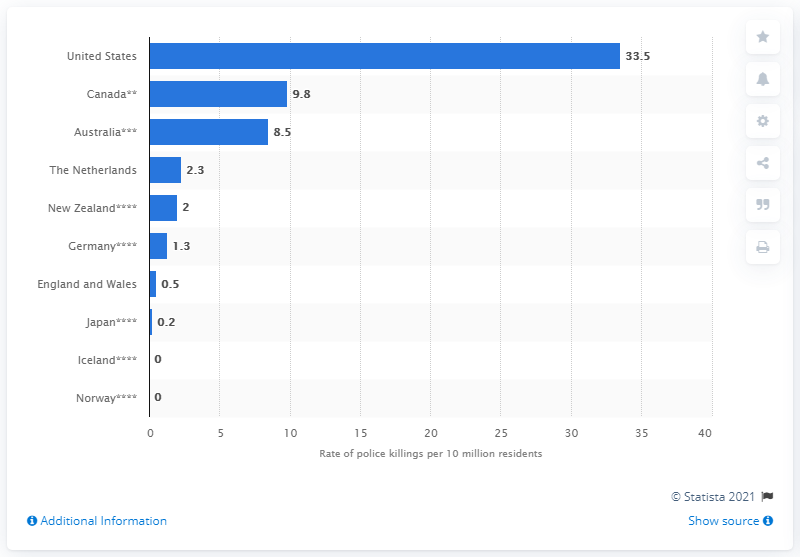Draw attention to some important aspects in this diagram. In 2019, a total of 33.5 civilians were killed by police in the United States. According to recent statistics, the rate of civilians killed by police in Canada is approximately 9.8 per million population. 